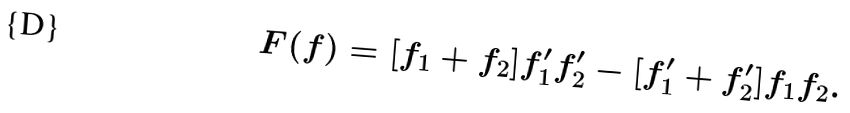<formula> <loc_0><loc_0><loc_500><loc_500>F ( f ) = [ f _ { 1 } + f _ { 2 } ] f ^ { \prime } _ { 1 } f ^ { \prime } _ { 2 } - [ f ^ { \prime } _ { 1 } + f ^ { \prime } _ { 2 } ] f _ { 1 } f _ { 2 } .</formula> 